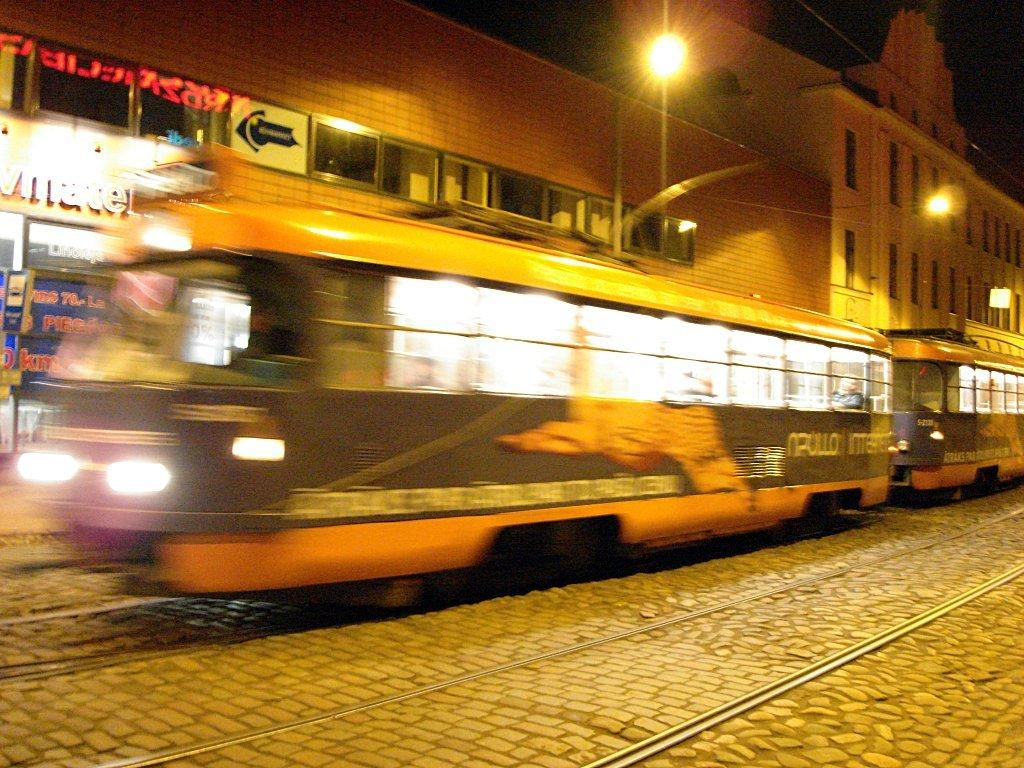What is the main subject in the center of the image? There are buses in the center of the image. What can be seen in the background of the image? There are buildings in the background of the image. What is the purpose of the object with a light on top in the image? There is a street light in the image, which provides illumination for the road. What is the surface on which the buses are traveling? There is a road at the bottom of the image. What type of friction can be observed between the buses and the road in the image? There is no specific type of friction mentioned or observable in the image; it is a general observation that buses travel on roads. --- Facts: 1. There is a person holding a camera in the image. 2. The person is standing on a bridge. 3. There is a river below the bridge. 4. There are trees on both sides of the river. Absurd Topics: parrot, bicycle, sand Conversation: What is the person in the image holding? The person in the image is holding a camera. Where is the person standing in the image? The person is standing on a bridge. What can be seen below the bridge in the image? There is a river below the bridge. What type of vegetation is present on both sides of the river? There are trees on both sides of the river. Reasoning: Let's think step by step in order to produce the conversation. We start by identifying the main subject in the image, which is the person holding a camera. Then, we expand the conversation to include other elements in the image, such as the bridge, the river, and the trees. Each question is designed to elicit a specific detail about the image that is known from the provided facts. Absurd Question/Answer: Can you see a parrot perched on the person's shoulder in the image? No, there is no parrot present in the image. 